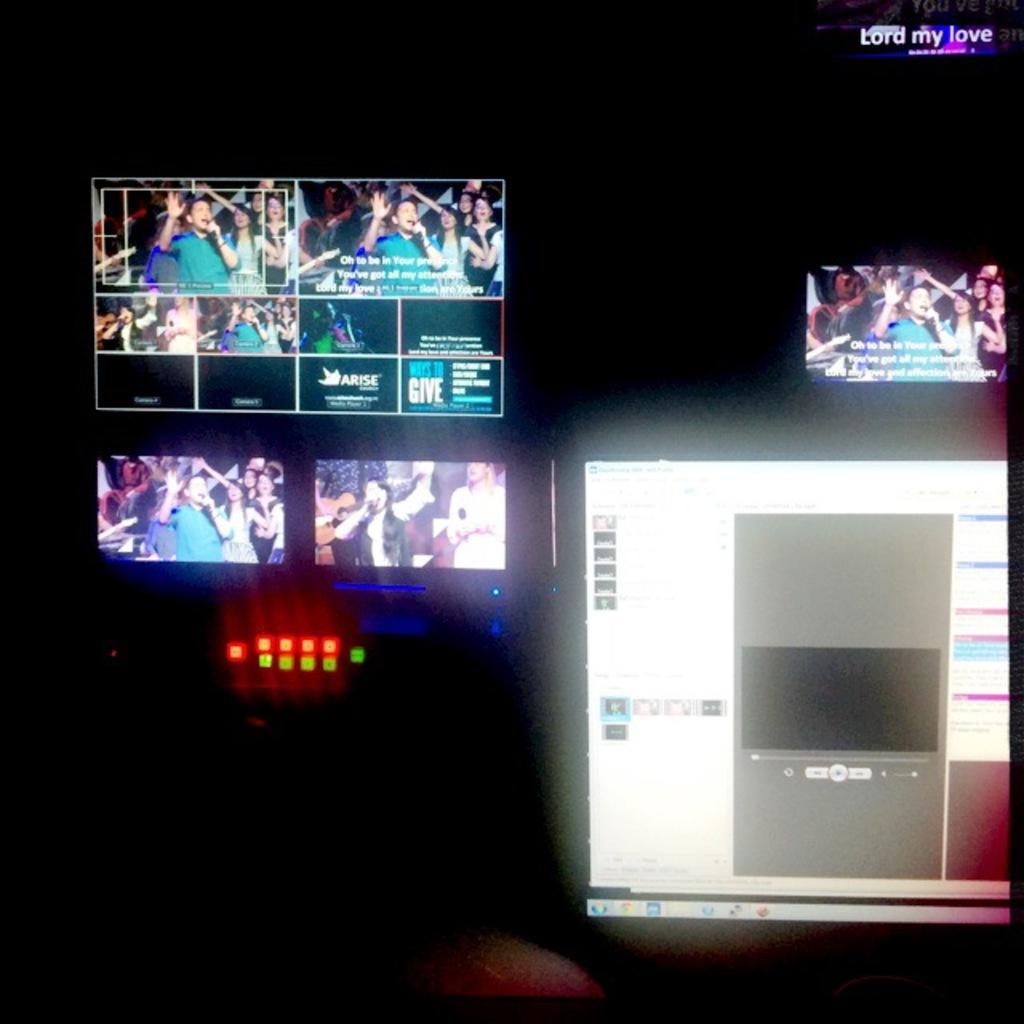What is present on the screens in the image? The screens display images and text. What can be observed about the background of the image? The background of the image is dark. What color is the crayon used to draw on the screens in the image? There is no crayon present in the image, and therefore no color can be determined. 